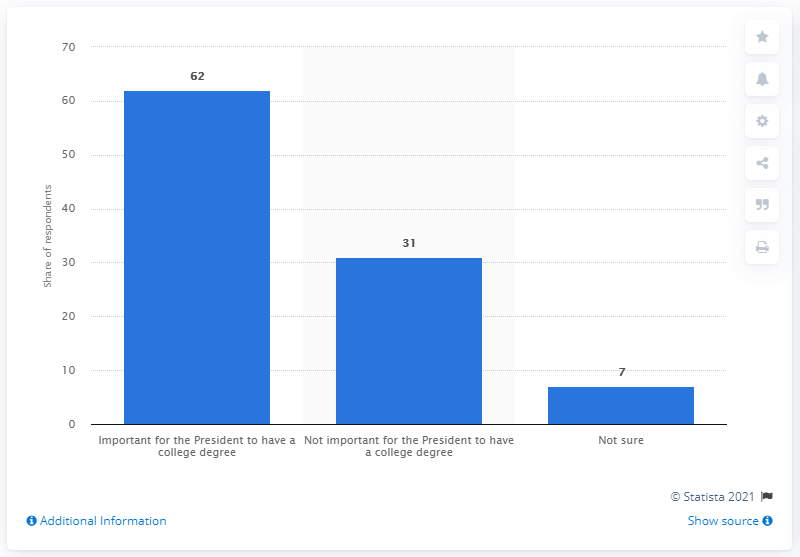Give some essential details in this illustration. 62% of respondents stated that it is important for a President to have a college degree. 